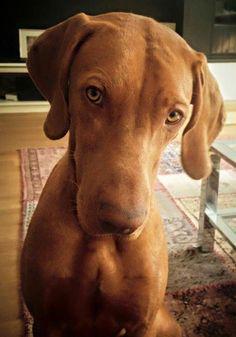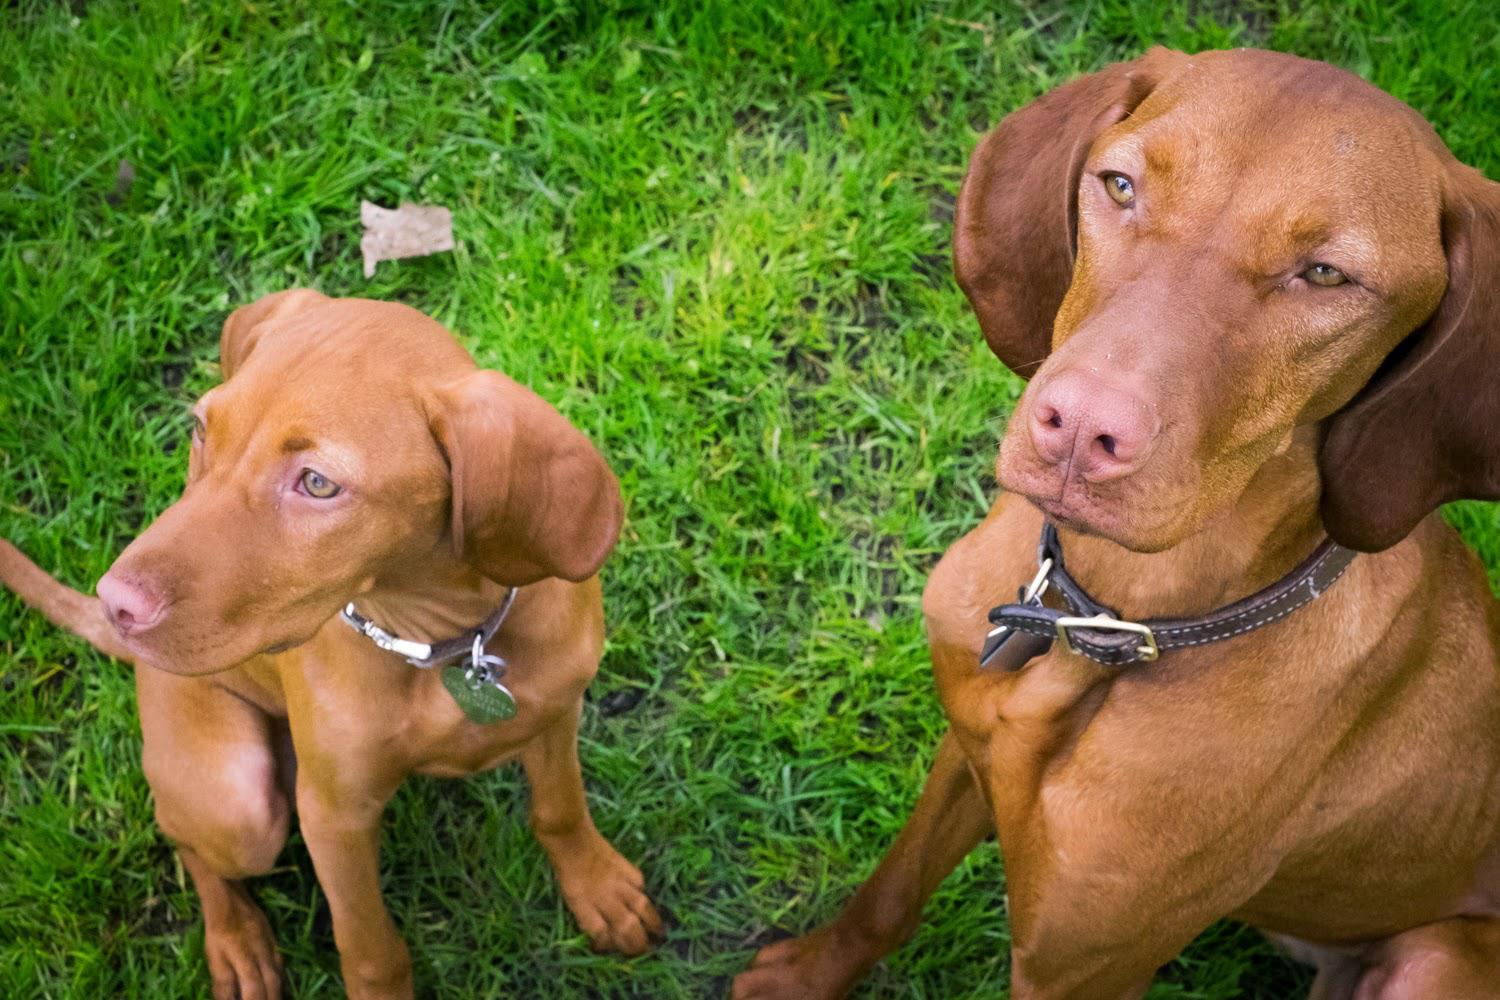The first image is the image on the left, the second image is the image on the right. For the images shown, is this caption "There is a dog wearing a red collar in each image." true? Answer yes or no. No. The first image is the image on the left, the second image is the image on the right. Assess this claim about the two images: "There is the same number of dogs in both images.". Correct or not? Answer yes or no. No. 